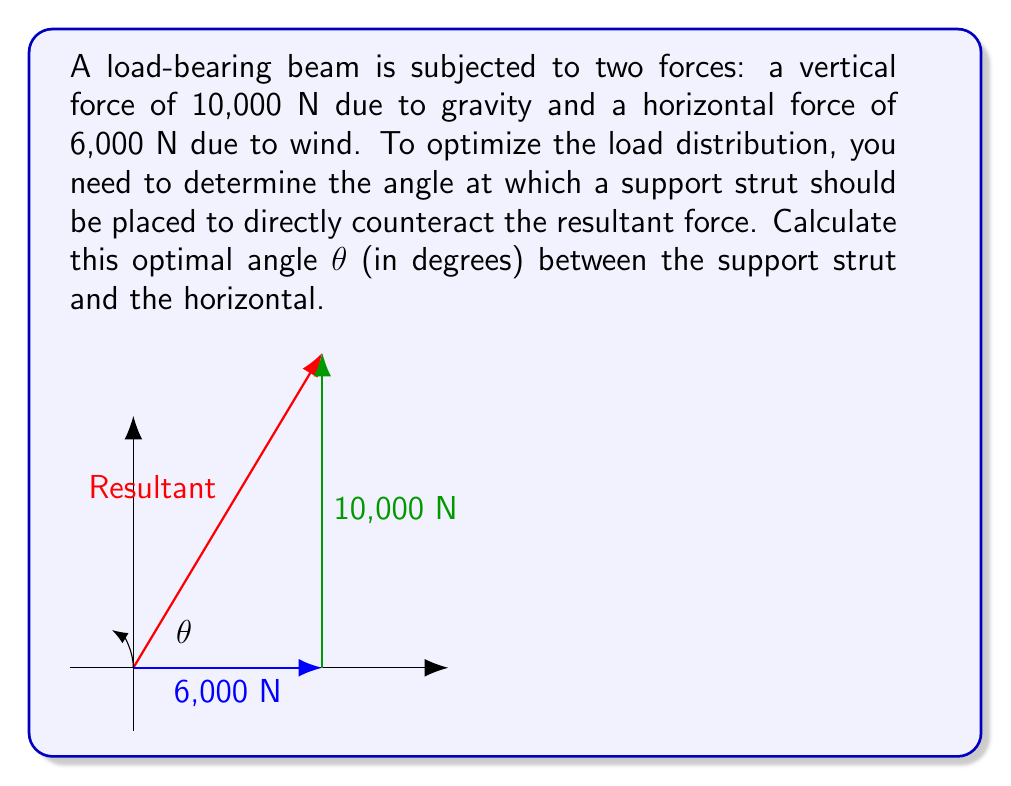Show me your answer to this math problem. To solve this problem, we'll use vector analysis:

1) First, let's identify our vectors:
   - Horizontal force: $\vec{F_h} = 6000\hat{i}$ N
   - Vertical force: $\vec{F_v} = 10000\hat{j}$ N

2) The resultant force $\vec{R}$ is the sum of these vectors:
   $\vec{R} = \vec{F_h} + \vec{F_v} = 6000\hat{i} + 10000\hat{j}$ N

3) To find the optimal angle, we need to calculate the angle this resultant makes with the horizontal. We can use the arctangent function for this:

   $\theta = \arctan(\frac{y}{x}) = \arctan(\frac{10000}{6000})$

4) Simplifying the fraction inside the arctangent:
   $\theta = \arctan(\frac{5}{3})$

5) Calculate this value:
   $\theta \approx 59.04^{\circ}$

6) This angle is measured from the horizontal to the resultant force vector. The support strut should be placed at this same angle to directly counteract the resultant force.

Therefore, the optimal angle for the support strut is approximately 59.04° from the horizontal.
Answer: $59.04^{\circ}$ 